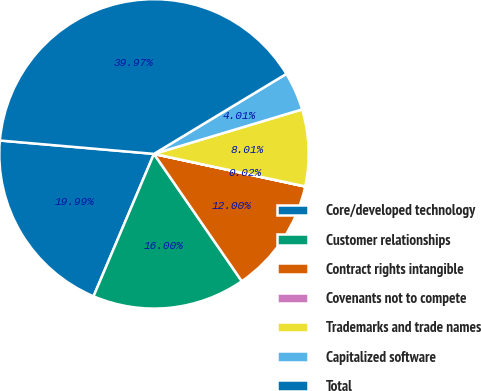Convert chart to OTSL. <chart><loc_0><loc_0><loc_500><loc_500><pie_chart><fcel>Core/developed technology<fcel>Customer relationships<fcel>Contract rights intangible<fcel>Covenants not to compete<fcel>Trademarks and trade names<fcel>Capitalized software<fcel>Total<nl><fcel>19.99%<fcel>16.0%<fcel>12.0%<fcel>0.02%<fcel>8.01%<fcel>4.01%<fcel>39.97%<nl></chart> 